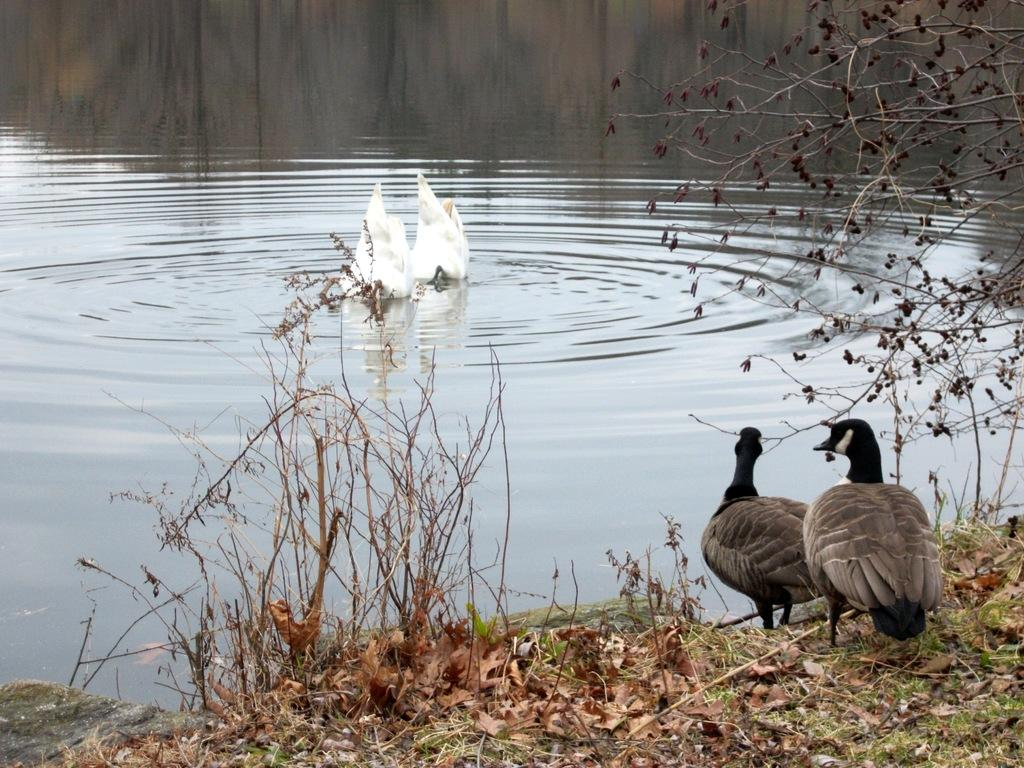What is the main subject of the image? The main subjects of the image are two birds on the surface of the water and two birds on the grass. What type of vegetation is visible in the image? There are dried plants and trees visible in the image. Can you describe the condition of the tree in the image? There is a dried tree in the image. What type of crime is being committed by the birds in the image? There is no crime being committed by the birds in the image; they are simply resting on the water and grass. 